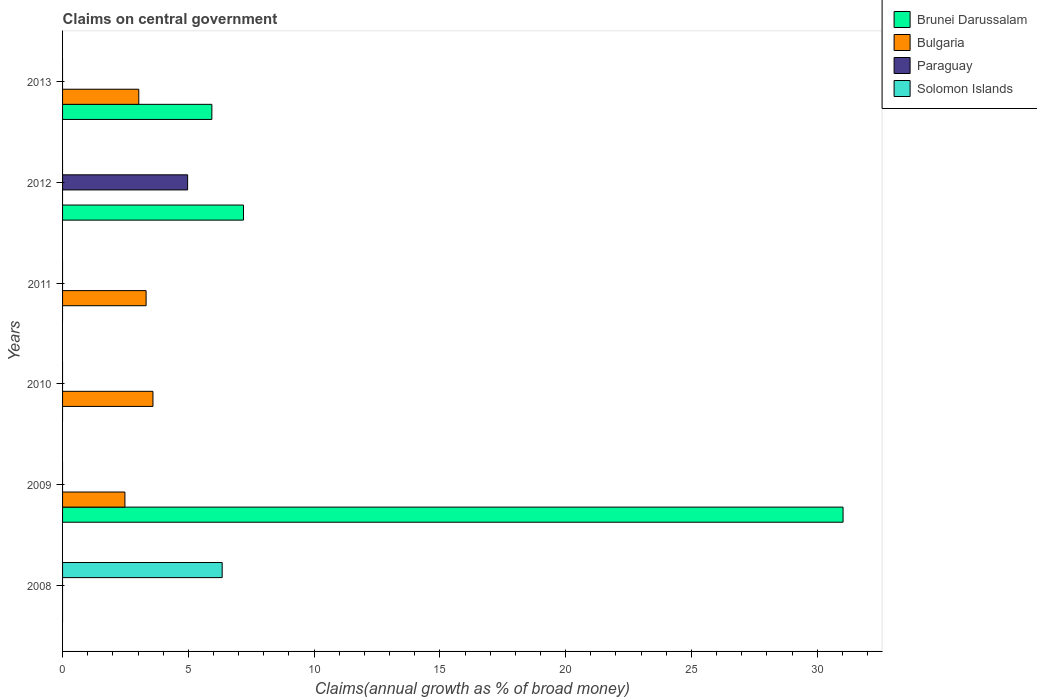How many different coloured bars are there?
Ensure brevity in your answer.  4. Are the number of bars per tick equal to the number of legend labels?
Offer a very short reply. No. What is the percentage of broad money claimed on centeral government in Brunei Darussalam in 2009?
Your response must be concise. 31.03. Across all years, what is the maximum percentage of broad money claimed on centeral government in Brunei Darussalam?
Your response must be concise. 31.03. Across all years, what is the minimum percentage of broad money claimed on centeral government in Brunei Darussalam?
Your answer should be very brief. 0. In which year was the percentage of broad money claimed on centeral government in Brunei Darussalam maximum?
Offer a very short reply. 2009. What is the total percentage of broad money claimed on centeral government in Paraguay in the graph?
Provide a short and direct response. 4.97. What is the difference between the percentage of broad money claimed on centeral government in Brunei Darussalam in 2012 and that in 2013?
Give a very brief answer. 1.26. What is the difference between the percentage of broad money claimed on centeral government in Solomon Islands in 2009 and the percentage of broad money claimed on centeral government in Paraguay in 2008?
Your answer should be compact. 0. What is the average percentage of broad money claimed on centeral government in Solomon Islands per year?
Provide a succinct answer. 1.06. What is the ratio of the percentage of broad money claimed on centeral government in Bulgaria in 2009 to that in 2011?
Give a very brief answer. 0.75. What is the difference between the highest and the second highest percentage of broad money claimed on centeral government in Brunei Darussalam?
Ensure brevity in your answer.  23.84. What is the difference between the highest and the lowest percentage of broad money claimed on centeral government in Bulgaria?
Offer a terse response. 3.59. In how many years, is the percentage of broad money claimed on centeral government in Solomon Islands greater than the average percentage of broad money claimed on centeral government in Solomon Islands taken over all years?
Your answer should be very brief. 1. Is it the case that in every year, the sum of the percentage of broad money claimed on centeral government in Paraguay and percentage of broad money claimed on centeral government in Bulgaria is greater than the sum of percentage of broad money claimed on centeral government in Brunei Darussalam and percentage of broad money claimed on centeral government in Solomon Islands?
Make the answer very short. No. Is it the case that in every year, the sum of the percentage of broad money claimed on centeral government in Brunei Darussalam and percentage of broad money claimed on centeral government in Paraguay is greater than the percentage of broad money claimed on centeral government in Solomon Islands?
Keep it short and to the point. No. Are all the bars in the graph horizontal?
Keep it short and to the point. Yes. How many years are there in the graph?
Your answer should be compact. 6. Where does the legend appear in the graph?
Offer a very short reply. Top right. How many legend labels are there?
Your answer should be very brief. 4. What is the title of the graph?
Ensure brevity in your answer.  Claims on central government. Does "Hungary" appear as one of the legend labels in the graph?
Offer a very short reply. No. What is the label or title of the X-axis?
Your response must be concise. Claims(annual growth as % of broad money). What is the Claims(annual growth as % of broad money) in Bulgaria in 2008?
Provide a succinct answer. 0. What is the Claims(annual growth as % of broad money) of Solomon Islands in 2008?
Give a very brief answer. 6.34. What is the Claims(annual growth as % of broad money) of Brunei Darussalam in 2009?
Make the answer very short. 31.03. What is the Claims(annual growth as % of broad money) in Bulgaria in 2009?
Ensure brevity in your answer.  2.48. What is the Claims(annual growth as % of broad money) of Solomon Islands in 2009?
Ensure brevity in your answer.  0. What is the Claims(annual growth as % of broad money) of Brunei Darussalam in 2010?
Ensure brevity in your answer.  0. What is the Claims(annual growth as % of broad money) of Bulgaria in 2010?
Keep it short and to the point. 3.59. What is the Claims(annual growth as % of broad money) of Paraguay in 2010?
Your answer should be compact. 0. What is the Claims(annual growth as % of broad money) of Bulgaria in 2011?
Make the answer very short. 3.32. What is the Claims(annual growth as % of broad money) of Paraguay in 2011?
Provide a succinct answer. 0. What is the Claims(annual growth as % of broad money) of Brunei Darussalam in 2012?
Offer a very short reply. 7.19. What is the Claims(annual growth as % of broad money) in Bulgaria in 2012?
Your answer should be compact. 0. What is the Claims(annual growth as % of broad money) of Paraguay in 2012?
Keep it short and to the point. 4.97. What is the Claims(annual growth as % of broad money) in Brunei Darussalam in 2013?
Offer a terse response. 5.93. What is the Claims(annual growth as % of broad money) of Bulgaria in 2013?
Give a very brief answer. 3.03. What is the Claims(annual growth as % of broad money) in Paraguay in 2013?
Provide a short and direct response. 0. What is the Claims(annual growth as % of broad money) in Solomon Islands in 2013?
Your response must be concise. 0. Across all years, what is the maximum Claims(annual growth as % of broad money) of Brunei Darussalam?
Your answer should be very brief. 31.03. Across all years, what is the maximum Claims(annual growth as % of broad money) in Bulgaria?
Offer a very short reply. 3.59. Across all years, what is the maximum Claims(annual growth as % of broad money) in Paraguay?
Provide a succinct answer. 4.97. Across all years, what is the maximum Claims(annual growth as % of broad money) in Solomon Islands?
Your answer should be compact. 6.34. Across all years, what is the minimum Claims(annual growth as % of broad money) in Paraguay?
Offer a very short reply. 0. Across all years, what is the minimum Claims(annual growth as % of broad money) in Solomon Islands?
Make the answer very short. 0. What is the total Claims(annual growth as % of broad money) in Brunei Darussalam in the graph?
Provide a succinct answer. 44.15. What is the total Claims(annual growth as % of broad money) in Bulgaria in the graph?
Keep it short and to the point. 12.42. What is the total Claims(annual growth as % of broad money) of Paraguay in the graph?
Provide a short and direct response. 4.97. What is the total Claims(annual growth as % of broad money) of Solomon Islands in the graph?
Your response must be concise. 6.34. What is the difference between the Claims(annual growth as % of broad money) of Bulgaria in 2009 and that in 2010?
Make the answer very short. -1.11. What is the difference between the Claims(annual growth as % of broad money) of Bulgaria in 2009 and that in 2011?
Your answer should be compact. -0.84. What is the difference between the Claims(annual growth as % of broad money) of Brunei Darussalam in 2009 and that in 2012?
Make the answer very short. 23.84. What is the difference between the Claims(annual growth as % of broad money) in Brunei Darussalam in 2009 and that in 2013?
Give a very brief answer. 25.09. What is the difference between the Claims(annual growth as % of broad money) in Bulgaria in 2009 and that in 2013?
Provide a short and direct response. -0.55. What is the difference between the Claims(annual growth as % of broad money) of Bulgaria in 2010 and that in 2011?
Your answer should be compact. 0.27. What is the difference between the Claims(annual growth as % of broad money) of Bulgaria in 2010 and that in 2013?
Make the answer very short. 0.56. What is the difference between the Claims(annual growth as % of broad money) of Bulgaria in 2011 and that in 2013?
Make the answer very short. 0.29. What is the difference between the Claims(annual growth as % of broad money) in Brunei Darussalam in 2012 and that in 2013?
Your response must be concise. 1.26. What is the difference between the Claims(annual growth as % of broad money) in Brunei Darussalam in 2009 and the Claims(annual growth as % of broad money) in Bulgaria in 2010?
Make the answer very short. 27.43. What is the difference between the Claims(annual growth as % of broad money) of Brunei Darussalam in 2009 and the Claims(annual growth as % of broad money) of Bulgaria in 2011?
Provide a short and direct response. 27.71. What is the difference between the Claims(annual growth as % of broad money) of Brunei Darussalam in 2009 and the Claims(annual growth as % of broad money) of Paraguay in 2012?
Your response must be concise. 26.06. What is the difference between the Claims(annual growth as % of broad money) in Bulgaria in 2009 and the Claims(annual growth as % of broad money) in Paraguay in 2012?
Offer a very short reply. -2.49. What is the difference between the Claims(annual growth as % of broad money) in Brunei Darussalam in 2009 and the Claims(annual growth as % of broad money) in Bulgaria in 2013?
Offer a terse response. 28. What is the difference between the Claims(annual growth as % of broad money) of Bulgaria in 2010 and the Claims(annual growth as % of broad money) of Paraguay in 2012?
Offer a terse response. -1.38. What is the difference between the Claims(annual growth as % of broad money) of Bulgaria in 2011 and the Claims(annual growth as % of broad money) of Paraguay in 2012?
Your response must be concise. -1.65. What is the difference between the Claims(annual growth as % of broad money) in Brunei Darussalam in 2012 and the Claims(annual growth as % of broad money) in Bulgaria in 2013?
Provide a short and direct response. 4.16. What is the average Claims(annual growth as % of broad money) of Brunei Darussalam per year?
Provide a succinct answer. 7.36. What is the average Claims(annual growth as % of broad money) of Bulgaria per year?
Provide a succinct answer. 2.07. What is the average Claims(annual growth as % of broad money) in Paraguay per year?
Your response must be concise. 0.83. What is the average Claims(annual growth as % of broad money) of Solomon Islands per year?
Give a very brief answer. 1.06. In the year 2009, what is the difference between the Claims(annual growth as % of broad money) in Brunei Darussalam and Claims(annual growth as % of broad money) in Bulgaria?
Your response must be concise. 28.55. In the year 2012, what is the difference between the Claims(annual growth as % of broad money) in Brunei Darussalam and Claims(annual growth as % of broad money) in Paraguay?
Your response must be concise. 2.22. In the year 2013, what is the difference between the Claims(annual growth as % of broad money) in Brunei Darussalam and Claims(annual growth as % of broad money) in Bulgaria?
Ensure brevity in your answer.  2.9. What is the ratio of the Claims(annual growth as % of broad money) of Bulgaria in 2009 to that in 2010?
Keep it short and to the point. 0.69. What is the ratio of the Claims(annual growth as % of broad money) in Bulgaria in 2009 to that in 2011?
Keep it short and to the point. 0.75. What is the ratio of the Claims(annual growth as % of broad money) in Brunei Darussalam in 2009 to that in 2012?
Your answer should be compact. 4.31. What is the ratio of the Claims(annual growth as % of broad money) of Brunei Darussalam in 2009 to that in 2013?
Provide a short and direct response. 5.23. What is the ratio of the Claims(annual growth as % of broad money) of Bulgaria in 2009 to that in 2013?
Offer a terse response. 0.82. What is the ratio of the Claims(annual growth as % of broad money) in Bulgaria in 2010 to that in 2011?
Provide a succinct answer. 1.08. What is the ratio of the Claims(annual growth as % of broad money) of Bulgaria in 2010 to that in 2013?
Make the answer very short. 1.19. What is the ratio of the Claims(annual growth as % of broad money) of Bulgaria in 2011 to that in 2013?
Make the answer very short. 1.1. What is the ratio of the Claims(annual growth as % of broad money) of Brunei Darussalam in 2012 to that in 2013?
Your answer should be compact. 1.21. What is the difference between the highest and the second highest Claims(annual growth as % of broad money) in Brunei Darussalam?
Ensure brevity in your answer.  23.84. What is the difference between the highest and the second highest Claims(annual growth as % of broad money) in Bulgaria?
Your response must be concise. 0.27. What is the difference between the highest and the lowest Claims(annual growth as % of broad money) in Brunei Darussalam?
Make the answer very short. 31.03. What is the difference between the highest and the lowest Claims(annual growth as % of broad money) of Bulgaria?
Make the answer very short. 3.59. What is the difference between the highest and the lowest Claims(annual growth as % of broad money) in Paraguay?
Ensure brevity in your answer.  4.97. What is the difference between the highest and the lowest Claims(annual growth as % of broad money) in Solomon Islands?
Make the answer very short. 6.34. 